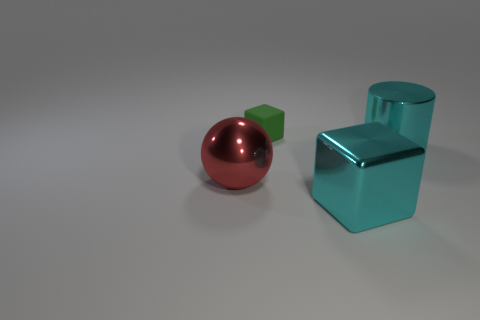What size is the cyan thing that is in front of the cyan object behind the big red object behind the metal cube?
Make the answer very short. Large. What number of rubber objects are large blue cylinders or tiny green cubes?
Ensure brevity in your answer.  1. The object behind the cyan metal cylinder is what color?
Your answer should be compact. Green. What is the shape of the red object that is the same size as the cyan cylinder?
Make the answer very short. Sphere. There is a big metallic cube; is its color the same as the large shiny object right of the large cyan cube?
Offer a terse response. Yes. What number of objects are large things to the right of the matte block or things left of the green rubber thing?
Offer a very short reply. 3. There is a cyan cube that is the same size as the red object; what material is it?
Give a very brief answer. Metal. How many other things are there of the same material as the red thing?
Ensure brevity in your answer.  2. Do the large cyan object in front of the shiny cylinder and the green thing that is on the left side of the large cyan shiny block have the same shape?
Give a very brief answer. Yes. What color is the thing that is to the right of the cyan thing in front of the shiny object behind the metal ball?
Make the answer very short. Cyan. 